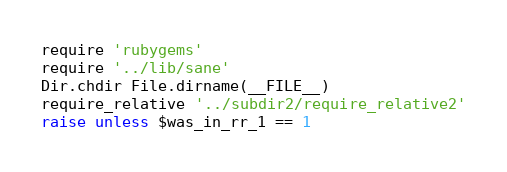Convert code to text. <code><loc_0><loc_0><loc_500><loc_500><_Ruby_>require 'rubygems'
require '../lib/sane'
Dir.chdir File.dirname(__FILE__)
require_relative '../subdir2/require_relative2'
raise unless $was_in_rr_1 == 1
</code> 